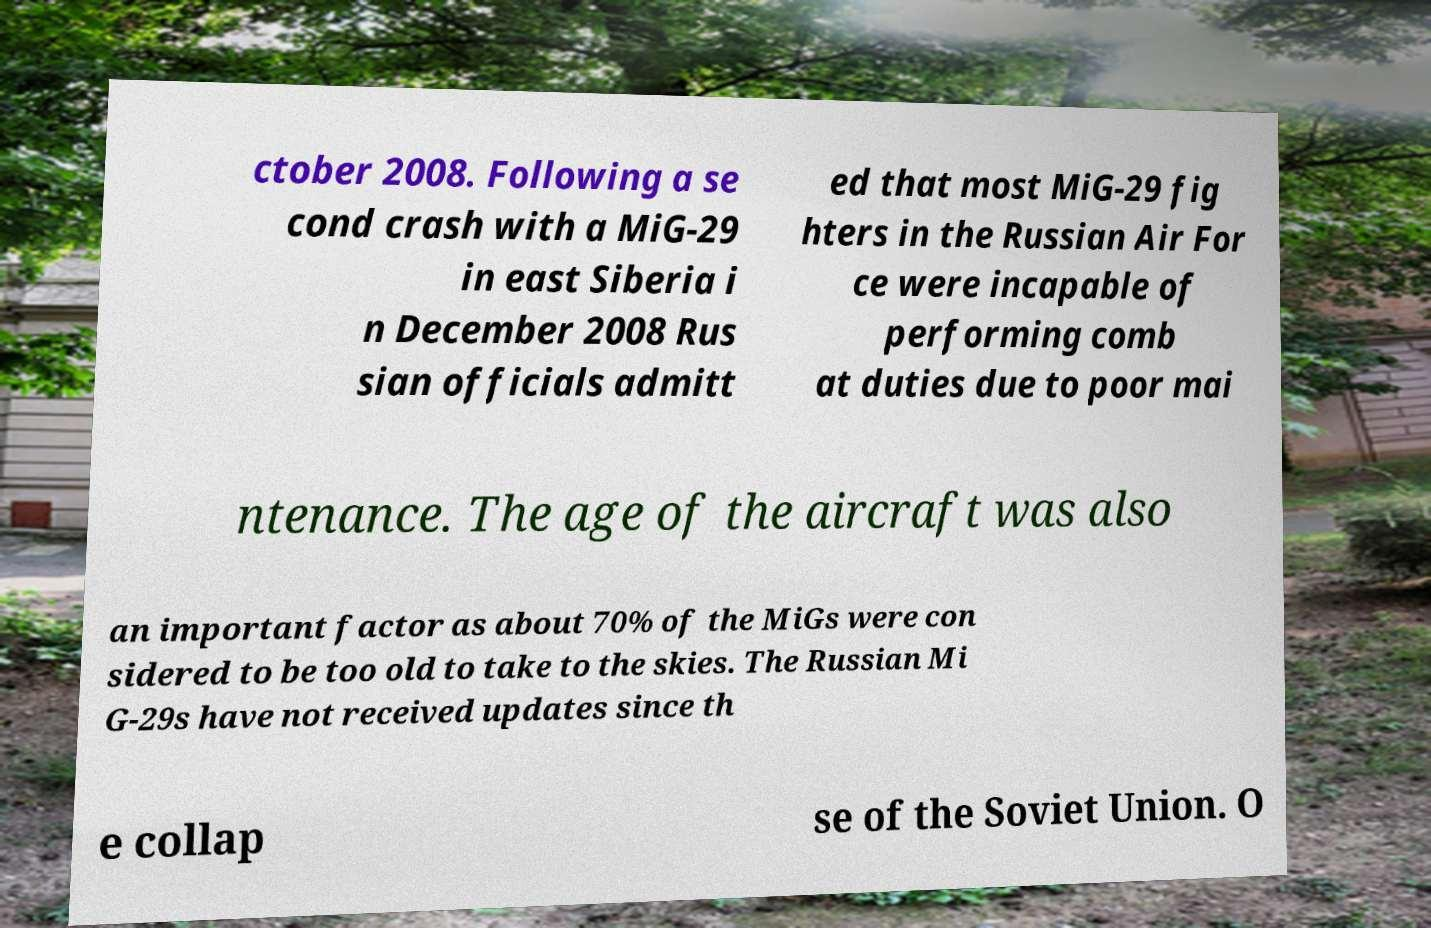For documentation purposes, I need the text within this image transcribed. Could you provide that? ctober 2008. Following a se cond crash with a MiG-29 in east Siberia i n December 2008 Rus sian officials admitt ed that most MiG-29 fig hters in the Russian Air For ce were incapable of performing comb at duties due to poor mai ntenance. The age of the aircraft was also an important factor as about 70% of the MiGs were con sidered to be too old to take to the skies. The Russian Mi G-29s have not received updates since th e collap se of the Soviet Union. O 